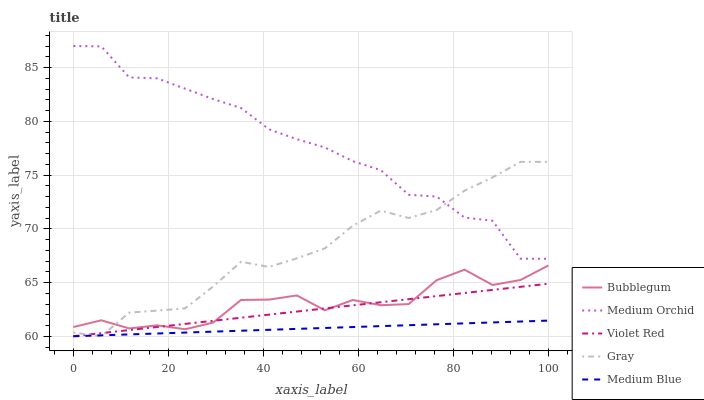Does Medium Blue have the minimum area under the curve?
Answer yes or no. Yes. Does Medium Orchid have the maximum area under the curve?
Answer yes or no. Yes. Does Violet Red have the minimum area under the curve?
Answer yes or no. No. Does Violet Red have the maximum area under the curve?
Answer yes or no. No. Is Medium Blue the smoothest?
Answer yes or no. Yes. Is Medium Orchid the roughest?
Answer yes or no. Yes. Is Violet Red the smoothest?
Answer yes or no. No. Is Violet Red the roughest?
Answer yes or no. No. Does Gray have the lowest value?
Answer yes or no. Yes. Does Medium Orchid have the lowest value?
Answer yes or no. No. Does Medium Orchid have the highest value?
Answer yes or no. Yes. Does Violet Red have the highest value?
Answer yes or no. No. Is Bubblegum less than Medium Orchid?
Answer yes or no. Yes. Is Medium Orchid greater than Medium Blue?
Answer yes or no. Yes. Does Gray intersect Medium Blue?
Answer yes or no. Yes. Is Gray less than Medium Blue?
Answer yes or no. No. Is Gray greater than Medium Blue?
Answer yes or no. No. Does Bubblegum intersect Medium Orchid?
Answer yes or no. No. 